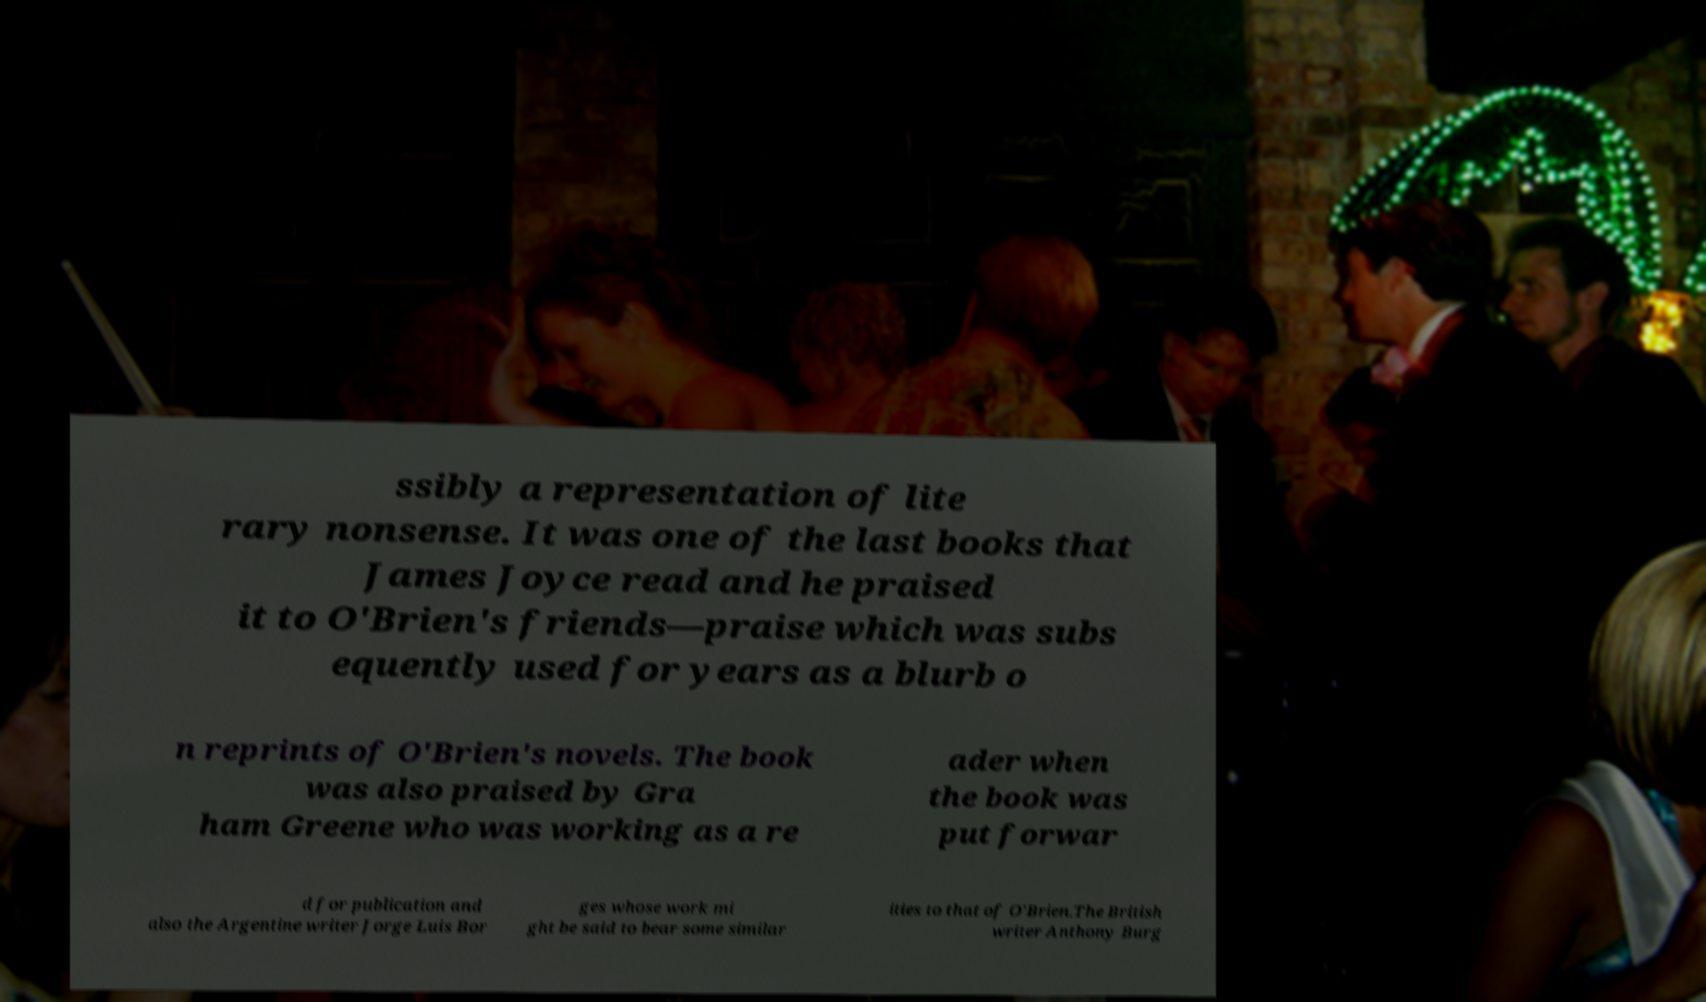Can you read and provide the text displayed in the image?This photo seems to have some interesting text. Can you extract and type it out for me? ssibly a representation of lite rary nonsense. It was one of the last books that James Joyce read and he praised it to O'Brien's friends—praise which was subs equently used for years as a blurb o n reprints of O'Brien's novels. The book was also praised by Gra ham Greene who was working as a re ader when the book was put forwar d for publication and also the Argentine writer Jorge Luis Bor ges whose work mi ght be said to bear some similar ities to that of O'Brien.The British writer Anthony Burg 